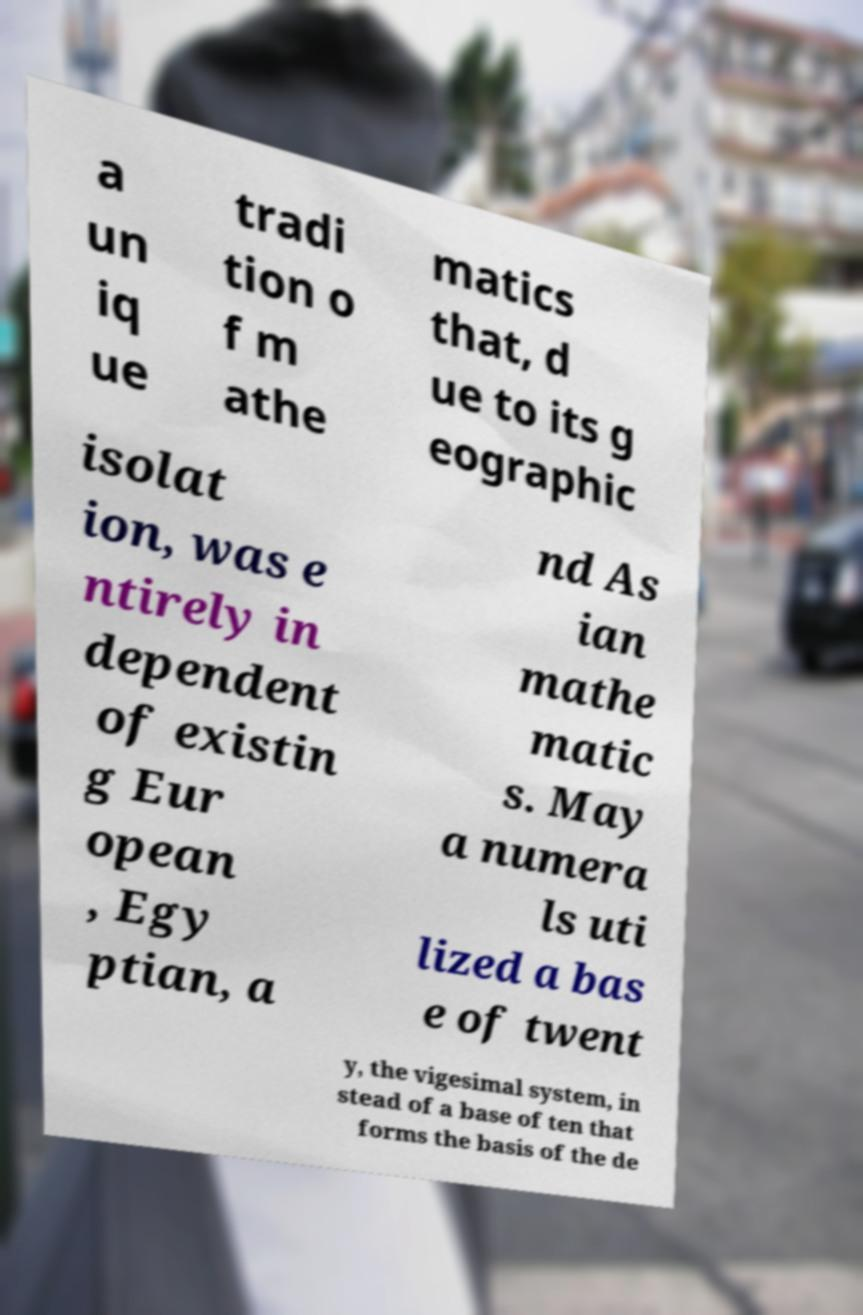Could you extract and type out the text from this image? a un iq ue tradi tion o f m athe matics that, d ue to its g eographic isolat ion, was e ntirely in dependent of existin g Eur opean , Egy ptian, a nd As ian mathe matic s. May a numera ls uti lized a bas e of twent y, the vigesimal system, in stead of a base of ten that forms the basis of the de 